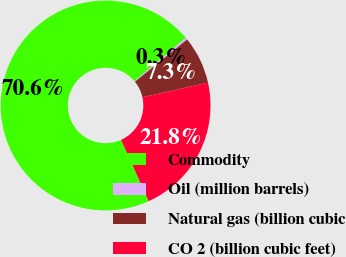<chart> <loc_0><loc_0><loc_500><loc_500><pie_chart><fcel>Commodity<fcel>Oil (million barrels)<fcel>Natural gas (billion cubic<fcel>CO 2 (billion cubic feet)<nl><fcel>70.58%<fcel>0.32%<fcel>7.34%<fcel>21.76%<nl></chart> 